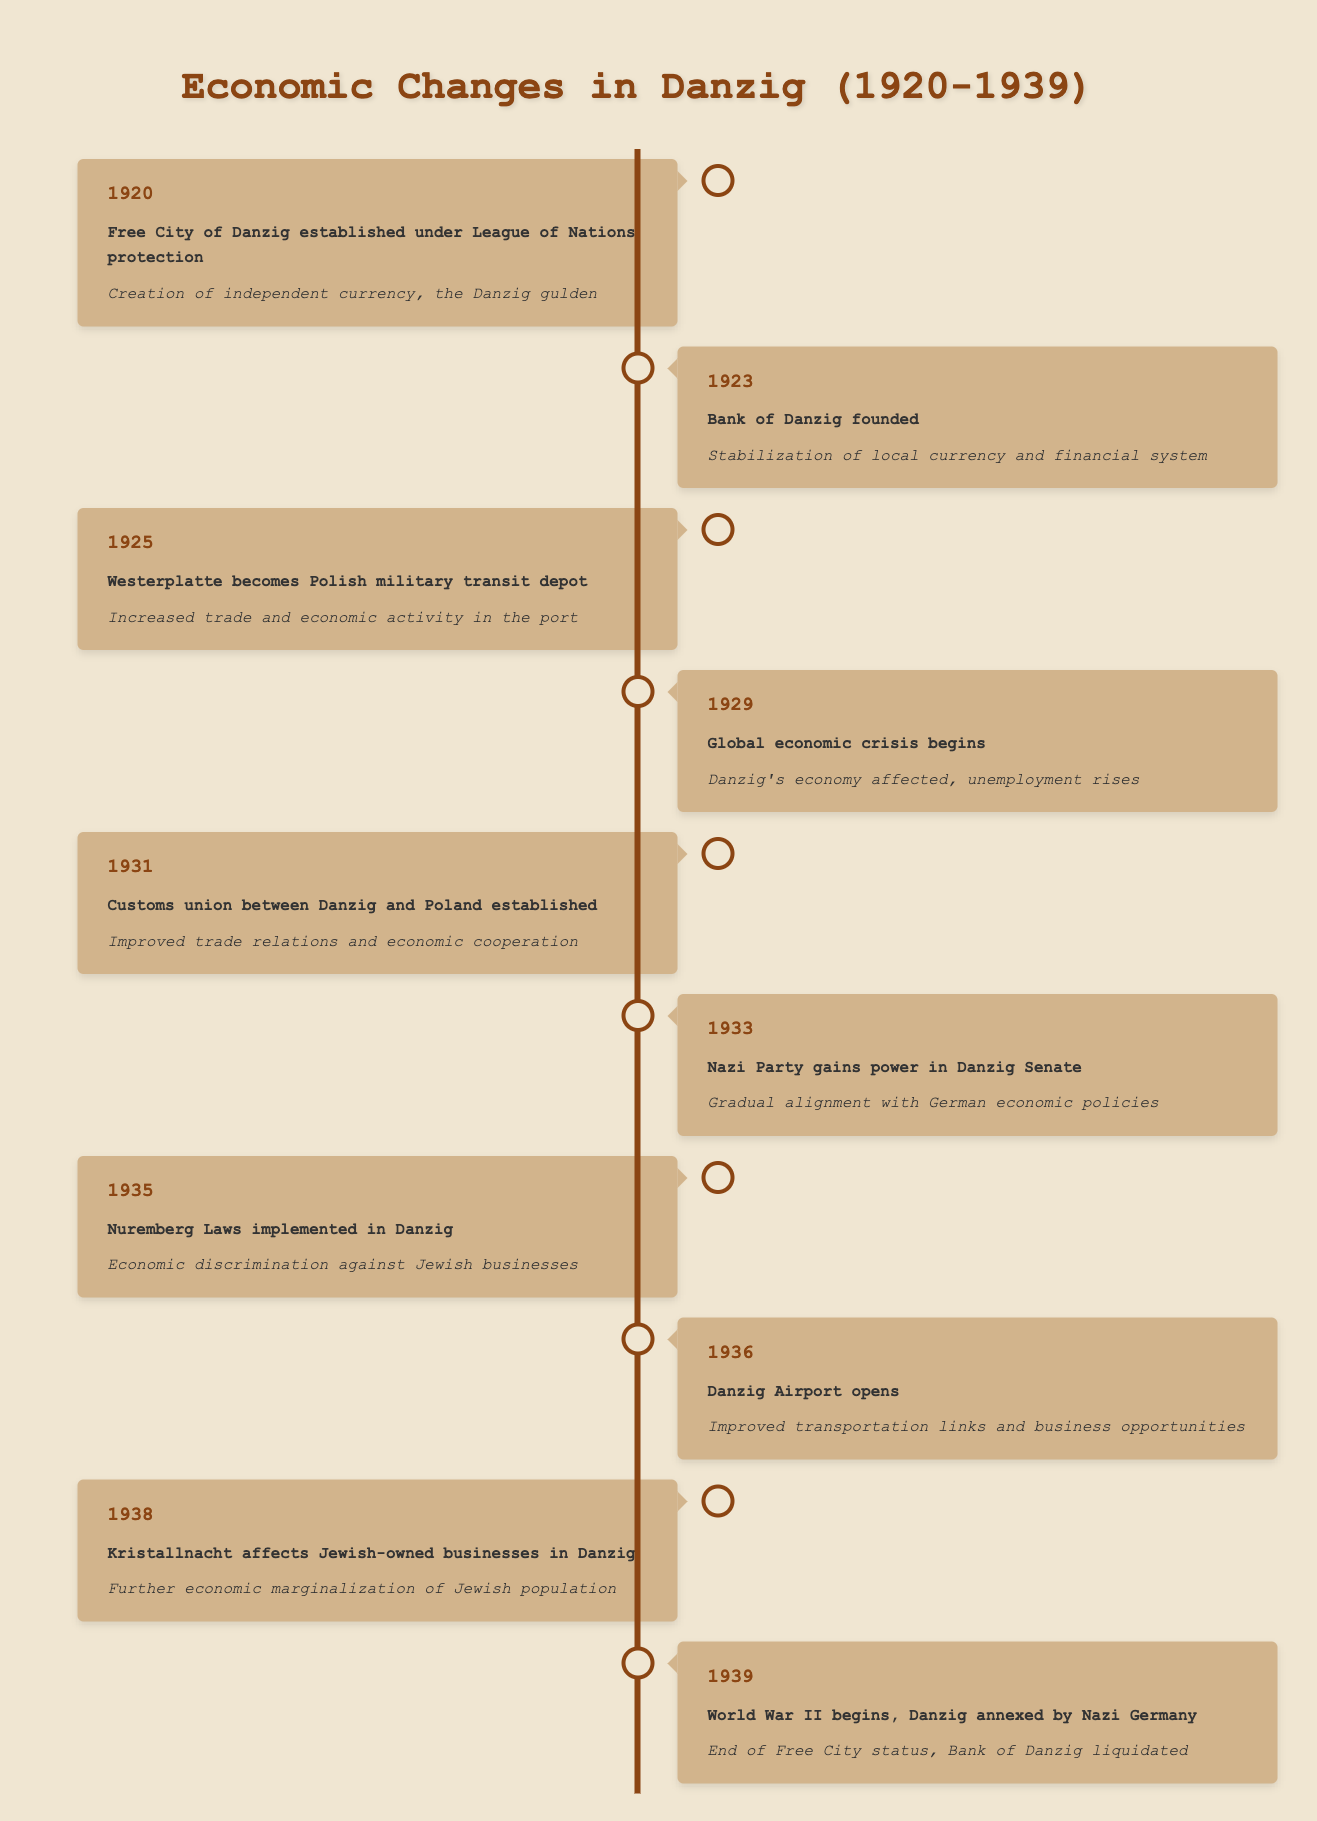What event marked the establishment of the Free City of Danzig? According to the table, in the year 1920, the Free City of Danzig was established under the protection of the League of Nations.
Answer: Free City of Danzig established under League of Nations protection What economic impact did the founding of the Bank of Danzig have? The table states that in 1923, when the Bank of Danzig was founded, it contributed to the stabilization of the local currency and financial system.
Answer: Stabilization of local currency and financial system Did Danzig's economy improve after the customs union with Poland was established? In 1931, the table indicates that the customs union between Danzig and Poland improved trade relations and economic cooperation, suggesting an overall improvement.
Answer: Yes What was the economic impact of the global economic crisis that began in 1929? According to the table, the economic crisis that began in 1929 affected Danzig's economy, leading to rising unemployment.
Answer: Danzig's economy affected, unemployment rises What is the year with the highest economic discrimination noted in Danzig? The table shows that in 1935, the implementation of the Nuremberg Laws led to economic discrimination against Jewish businesses, making it the year with the highest discrimination.
Answer: 1935 How many events in Danzig's economic history were noted between 1920 and 1939? By counting the events listed in the table, there are 10 events mentioned between 1920 and 1939.
Answer: 10 What were some of the major economic developments around 1936? The table indicates that in 1936, Danzig Airport opened, which improved transportation links and business opportunities, marking a significant economic development that year.
Answer: Danzig Airport opens Was there any event leading to the end of the Free City status? Yes, the table notes that in 1939, World War II began and Danzig was annexed by Nazi Germany, which led to the end of Free City status.
Answer: Yes What year did the Nazi Party begin to align with German economic policies in Danzig? According to the table, the Nazi Party gained power in the Danzig Senate in 1933, which marks the beginning of alignment with German economic policies.
Answer: 1933 